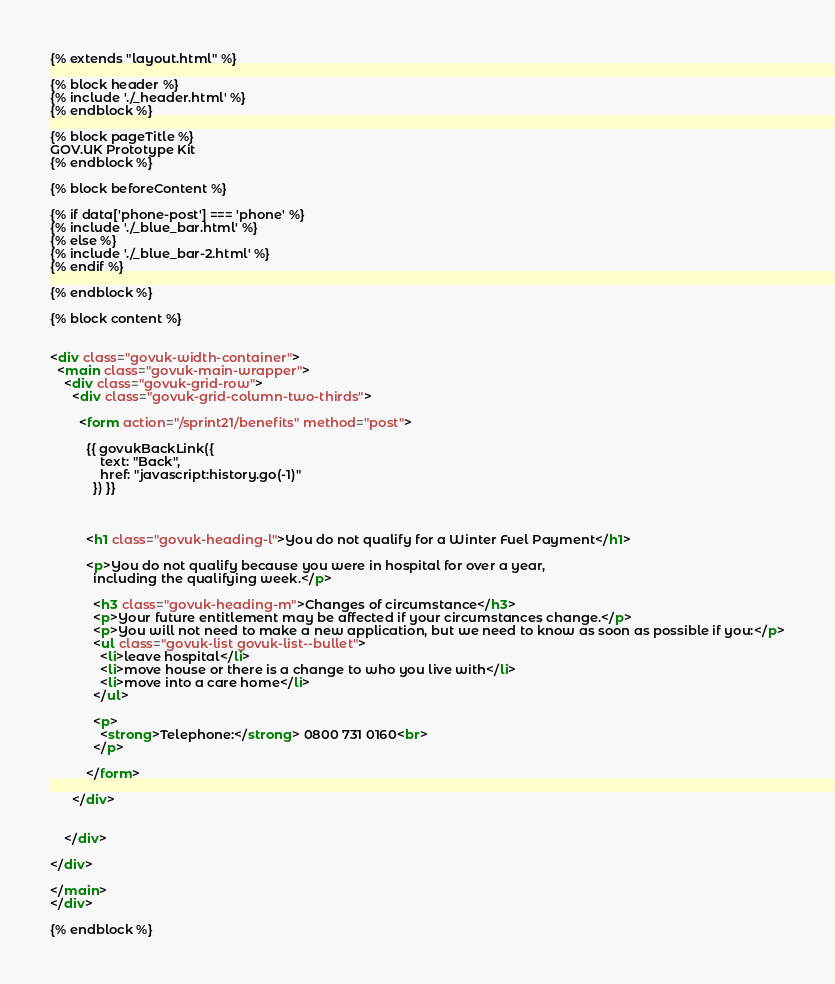<code> <loc_0><loc_0><loc_500><loc_500><_HTML_>{% extends "layout.html" %}

{% block header %}
{% include './_header.html' %}
{% endblock %}

{% block pageTitle %}
GOV.UK Prototype Kit
{% endblock %}

{% block beforeContent %}

{% if data['phone-post'] === 'phone' %}
{% include './_blue_bar.html' %}
{% else %}
{% include './_blue_bar-2.html' %}
{% endif %}

{% endblock %}

{% block content %}


<div class="govuk-width-container">
  <main class="govuk-main-wrapper">
    <div class="govuk-grid-row">
      <div class="govuk-grid-column-two-thirds">

        <form action="/sprint21/benefits" method="post">

          {{ govukBackLink({
              text: "Back",
              href: "javascript:history.go(-1)"
            }) }}



          <h1 class="govuk-heading-l">You do not qualify for a Winter Fuel Payment</h1>

          <p>You do not qualify because you were in hospital for over a year,
            including the qualifying week.</p>

            <h3 class="govuk-heading-m">Changes of circumstance</h3>
            <p>Your future entitlement may be affected if your circumstances change.</p>
            <p>You will not need to make a new application, but we need to know as soon as possible if you:</p>
            <ul class="govuk-list govuk-list--bullet">
              <li>leave hospital</li>
              <li>move house or there is a change to who you live with</li>
              <li>move into a care home</li>
            </ul>

            <p>
              <strong>Telephone:</strong> 0800 731 0160<br>
            </p>

          </form>

      </div>


    </div>

</div>

</main>
</div>

{% endblock %}
</code> 